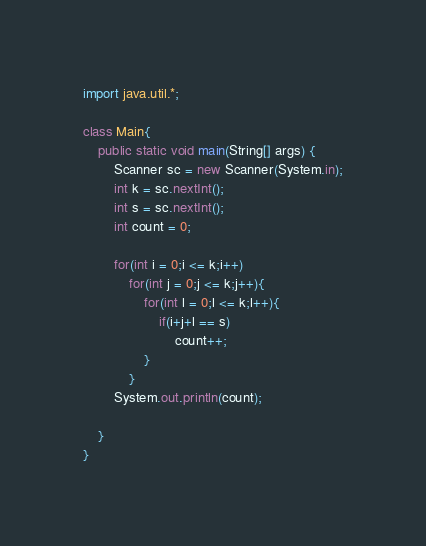<code> <loc_0><loc_0><loc_500><loc_500><_Java_>import java.util.*;

class Main{
    public static void main(String[] args) {
        Scanner sc = new Scanner(System.in);
        int k = sc.nextInt();
        int s = sc.nextInt();
        int count = 0;

        for(int i = 0;i <= k;i++)
            for(int j = 0;j <= k;j++){
                for(int l = 0;l <= k;l++){
                    if(i+j+l == s)
                        count++;
                }
            }
        System.out.println(count);

    }
}</code> 